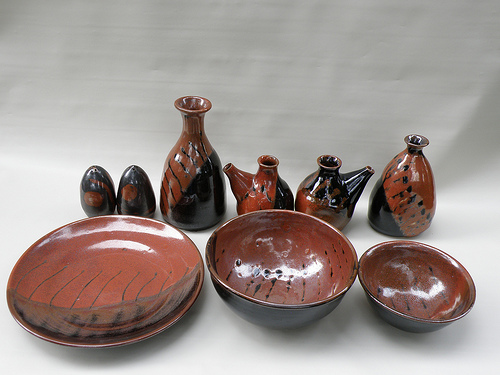Please provide the bounding box coordinate of the region this sentence describes: Small black and red bowl. The bounding box coordinates for the 'Small black and red bowl' are [0.71, 0.59, 0.97, 0.82]. This small, vibrant bowl adds a striking contrast to the scene. 